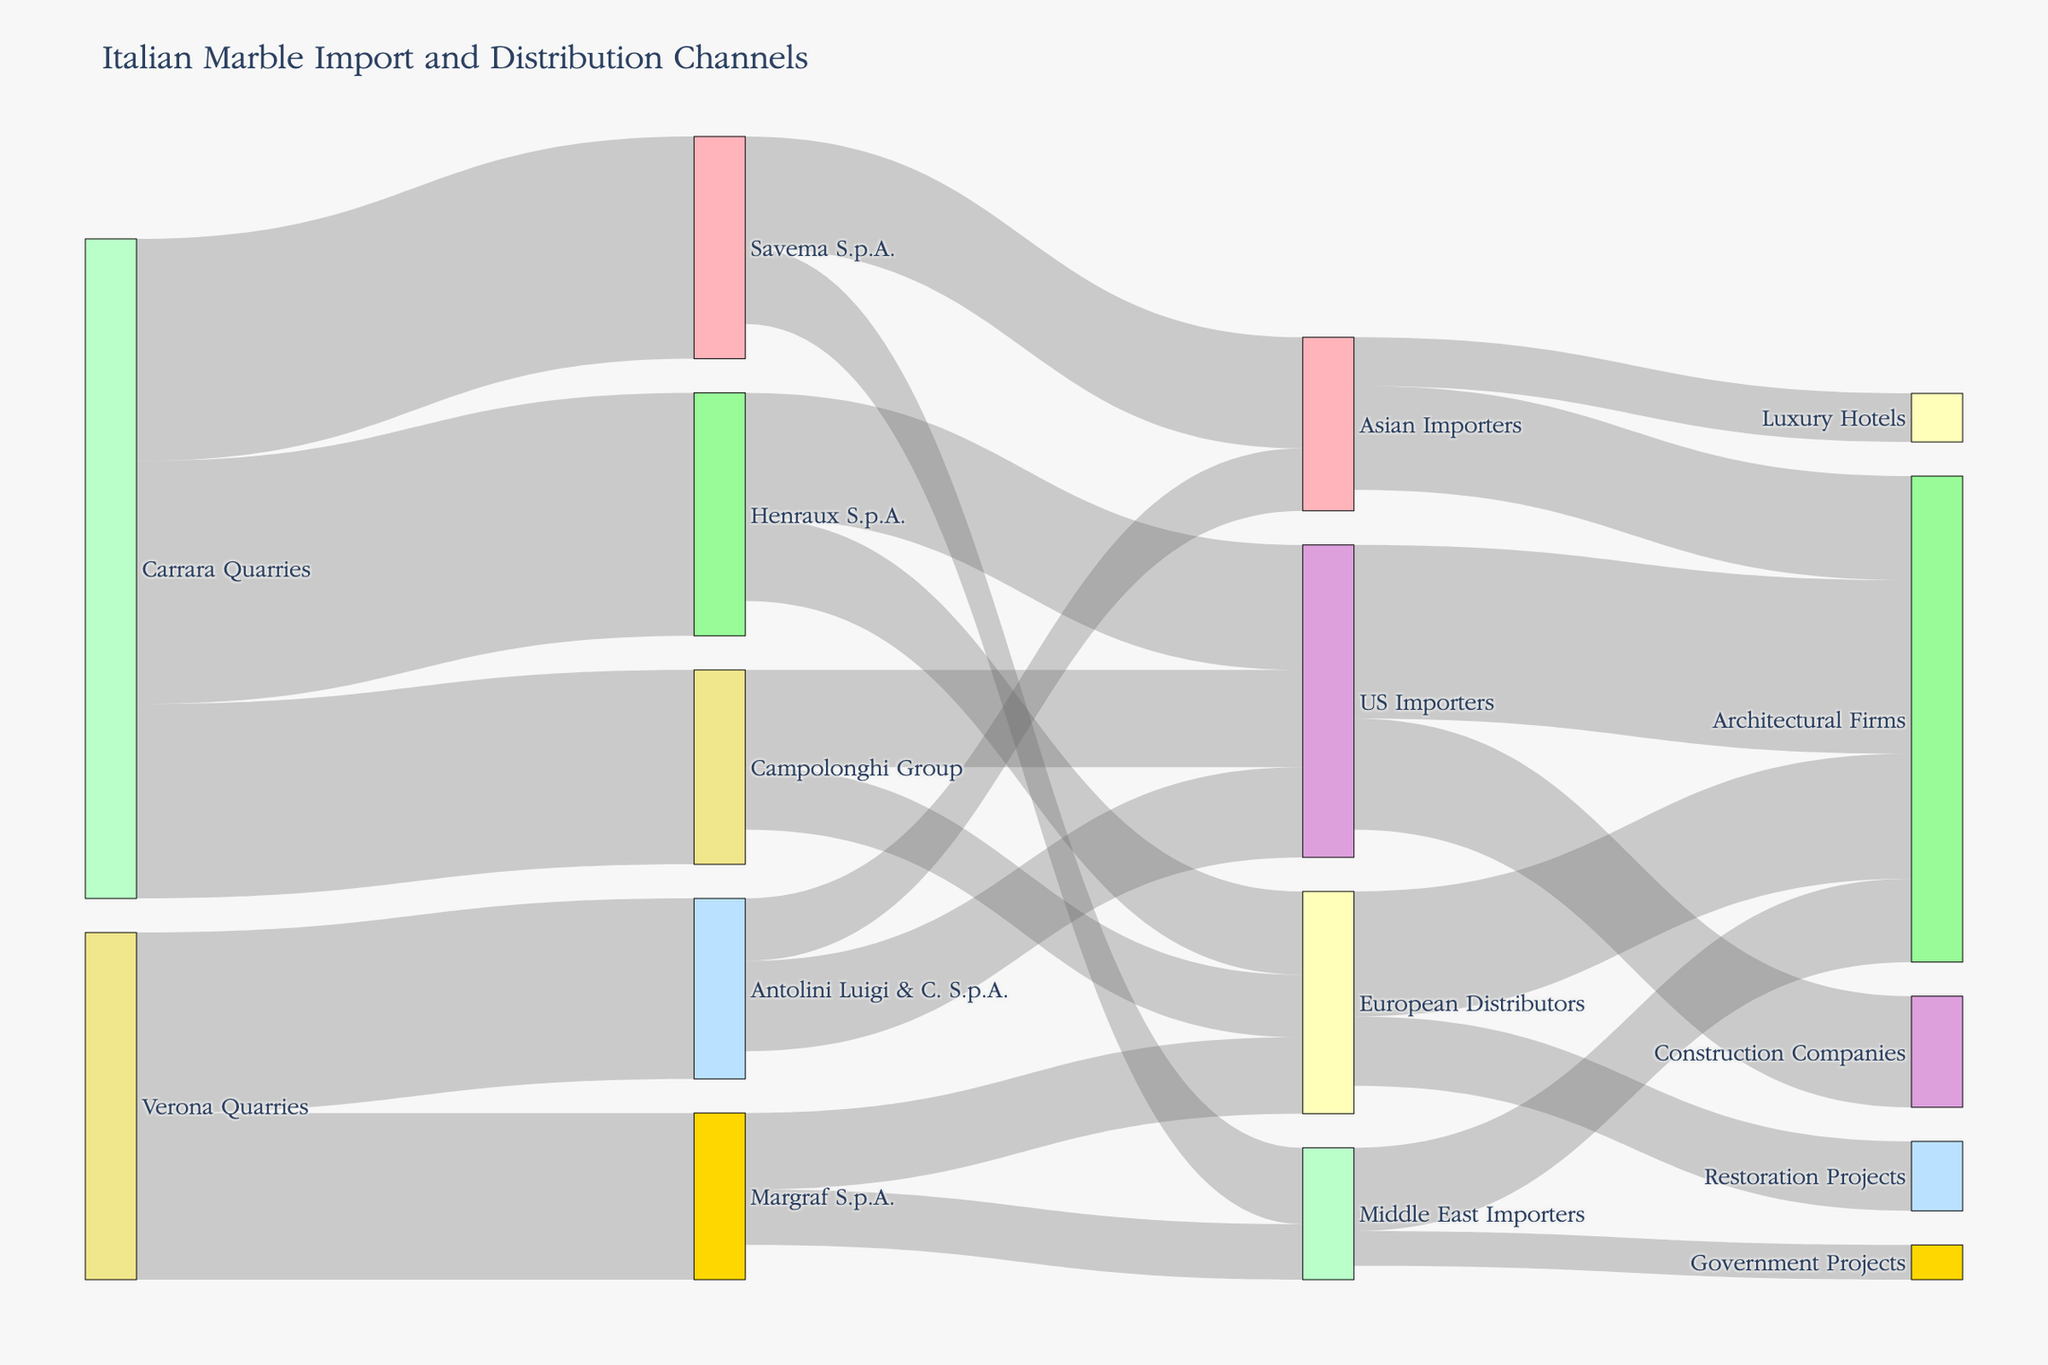What is the title of the figure? The title of the figure is typically displayed at the top of the plot. In this case, it's indicated in the code used to generate the plot.
Answer: Italian Marble Import and Distribution Channels Which quarry has the highest distribution to Henraux S.p.A.? By examining the diagram, we can identify the source nodes and their corresponding target nodes. The connection with the highest value between a quarry and Henraux S.p.A. represents the highest distribution.
Answer: Carrara Quarries How many importers does Savema S.p.A. supply marble to? To determine this, we need to count the number of target nodes directly linked to Savema S.p.A.
Answer: 2 What is the total value of marble distributed by Margraf S.p.A.? Add the values of the marble distributed by Margraf S.p.A. to its respective targets. The total value is the sum of these values. The values are 1100 and 800.
Answer: 1900 Which target receives the least amount of marble from Henraux S.p.A.? Compare the values of each target that receives marble from Henraux S.p.A. The smallest value among these is the answer. Henraux S.p.A. supplies 1800 to US Importers and 1200 to European Distributors.
Answer: European Distributors How much marble does Campolonghi Group send to US Importers compared to European Distributors? Look at the values linking Campolonghi Group to US Importers and European Distributors. The values are 1400 and 900, respectively. Subtract the smaller value from the larger value.
Answer: 500 What percentage of marble from Verona Quarries goes to Antolini Luigi & C. S.p.A.? Divide the value of marble distributed to Antolini Luigi & C. S.p.A. by the total value of marble from Verona Quarries, then multiply by 100. The distribution values from Verona Quarries are 2600 and 2400, and the value to Antolini Luigi & C. S.p.A. is 2600. So, (2600 / (2600 + 2400)) * 100.
Answer: 52% Which importer category receives the most marble from the Asian Importers? Compare the values of marble received by the sub-categories of importers within the Asian Importers.
Answer: Architectural Firms What is the combined total of marble received by government projects and luxury hotels? Add the values of marble that go to government projects and luxury hotels. The values are 500 and 700, respectively.
Answer: 1200 How many channels does marble from Carrara Quarries pass through before reaching architectural firms in the US? Trace the path from Carrara Quarries to architectural firms in the US, counting each distinct link in the path. Carrara Quarries → Henraux S.p.A. → US Importers → Architectural Firms.
Answer: 3 